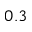<formula> <loc_0><loc_0><loc_500><loc_500>0 . 3</formula> 